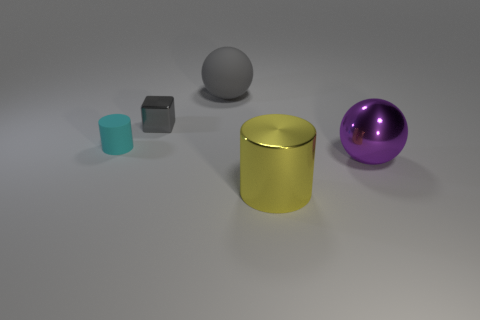Add 3 gray balls. How many objects exist? 8 Subtract all spheres. How many objects are left? 3 Add 3 yellow shiny cylinders. How many yellow shiny cylinders are left? 4 Add 2 tiny yellow objects. How many tiny yellow objects exist? 2 Subtract 0 brown blocks. How many objects are left? 5 Subtract all blue cylinders. Subtract all large yellow metallic cylinders. How many objects are left? 4 